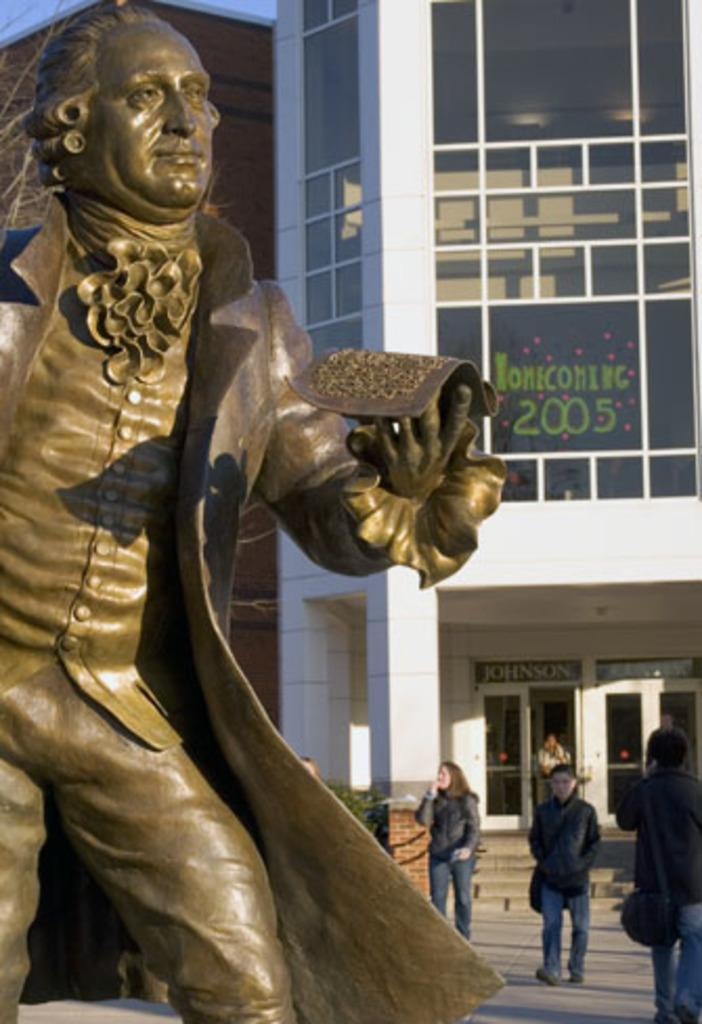What is the main subject in the image? There is a statue in the image. What else can be seen in the image besides the statue? There is a building in the image. Are there any living beings present in the image? Yes, there are people present in the image. What is the title of the book that the people are reading in the image? There is no book present in the image, so it is not possible to determine the title. 